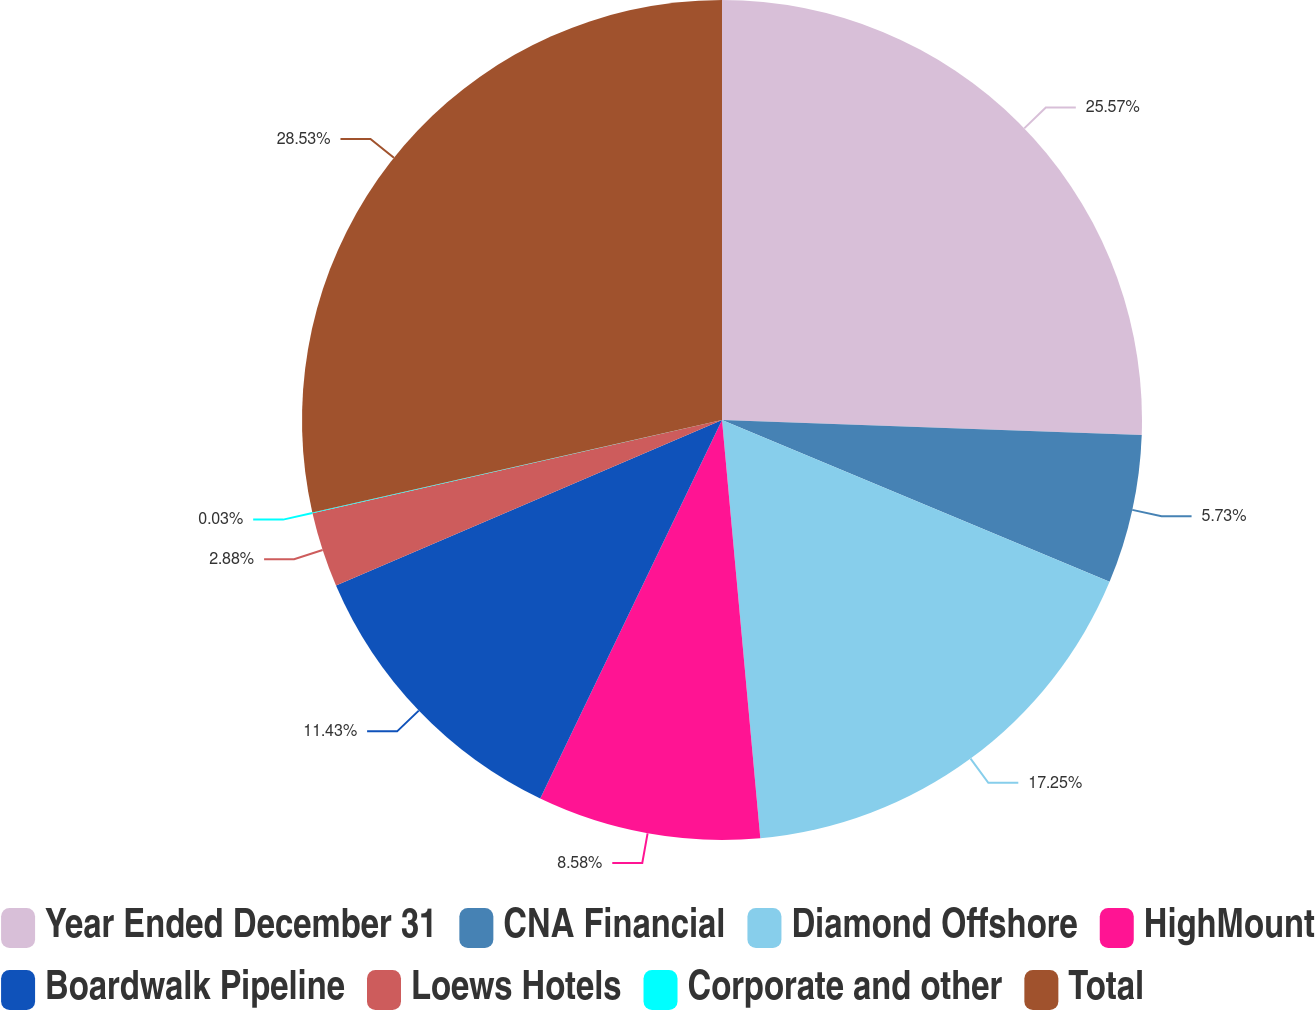Convert chart. <chart><loc_0><loc_0><loc_500><loc_500><pie_chart><fcel>Year Ended December 31<fcel>CNA Financial<fcel>Diamond Offshore<fcel>HighMount<fcel>Boardwalk Pipeline<fcel>Loews Hotels<fcel>Corporate and other<fcel>Total<nl><fcel>25.57%<fcel>5.73%<fcel>17.25%<fcel>8.58%<fcel>11.43%<fcel>2.88%<fcel>0.03%<fcel>28.54%<nl></chart> 